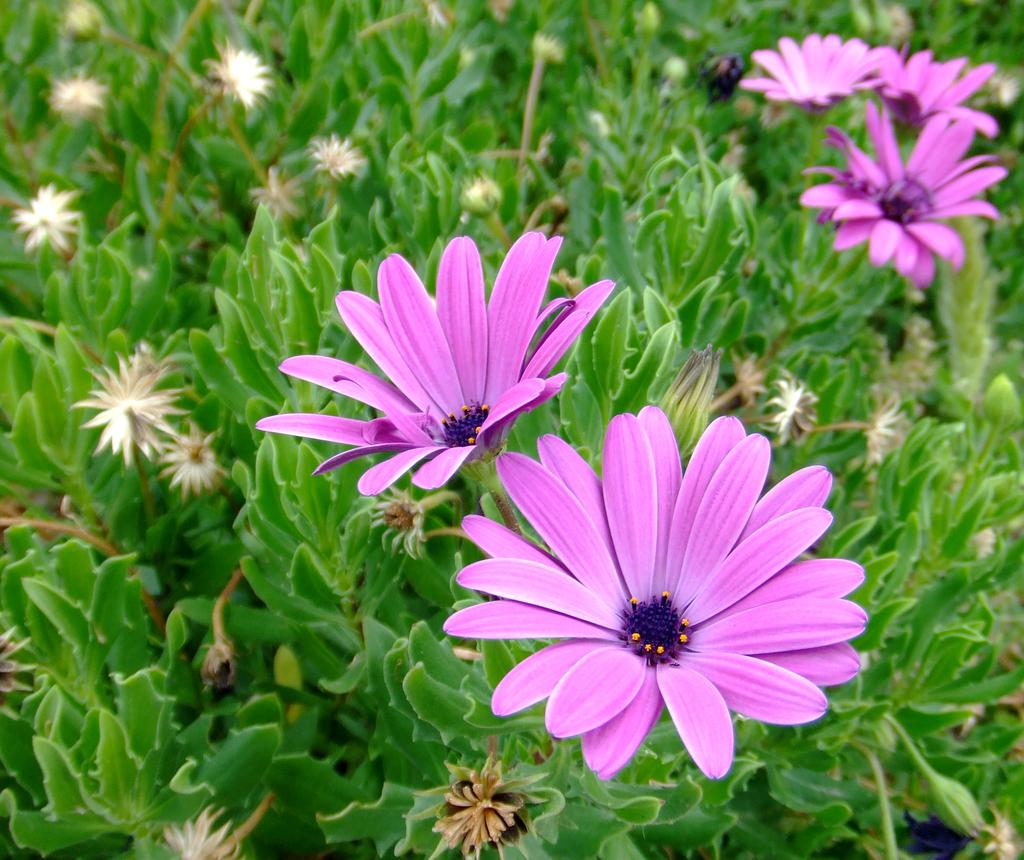What type of plants can be seen in the image? There are flowers and green leaves in the image. Can you describe the color of the flowers? The provided facts do not mention the color of the flowers. What is the color of the leaves in the image? The leaves in the image are green. What type of lace can be seen on the structure in the image? There is no structure or lace present in the image; it only features flowers and green leaves. 